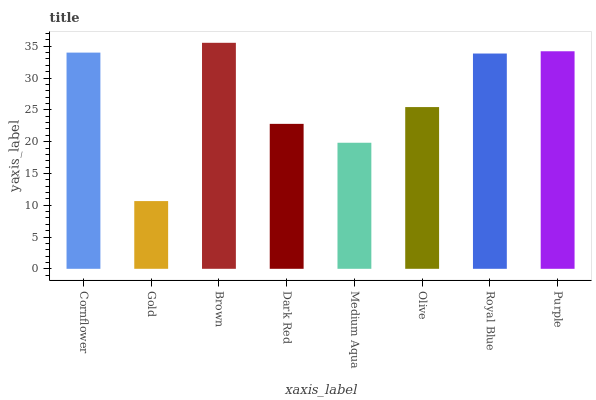Is Gold the minimum?
Answer yes or no. Yes. Is Brown the maximum?
Answer yes or no. Yes. Is Brown the minimum?
Answer yes or no. No. Is Gold the maximum?
Answer yes or no. No. Is Brown greater than Gold?
Answer yes or no. Yes. Is Gold less than Brown?
Answer yes or no. Yes. Is Gold greater than Brown?
Answer yes or no. No. Is Brown less than Gold?
Answer yes or no. No. Is Royal Blue the high median?
Answer yes or no. Yes. Is Olive the low median?
Answer yes or no. Yes. Is Purple the high median?
Answer yes or no. No. Is Brown the low median?
Answer yes or no. No. 